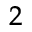Convert formula to latex. <formula><loc_0><loc_0><loc_500><loc_500>^ { 2 }</formula> 